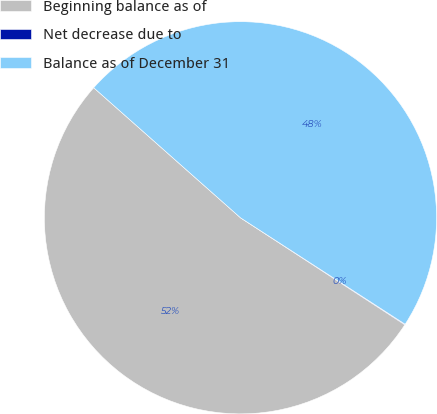Convert chart to OTSL. <chart><loc_0><loc_0><loc_500><loc_500><pie_chart><fcel>Beginning balance as of<fcel>Net decrease due to<fcel>Balance as of December 31<nl><fcel>52.36%<fcel>0.05%<fcel>47.6%<nl></chart> 